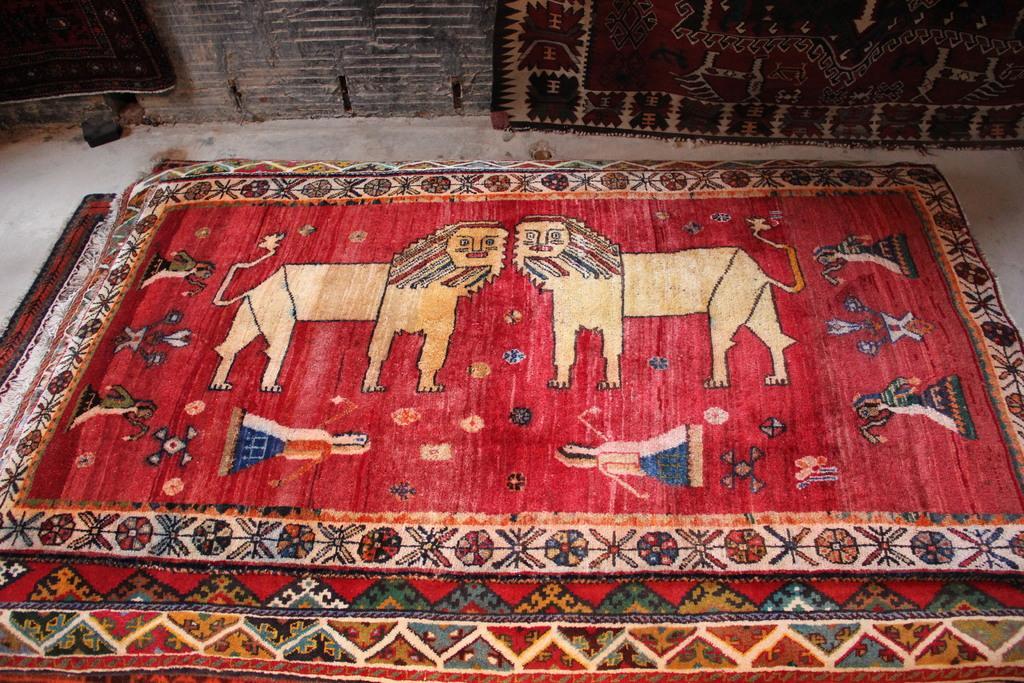In one or two sentences, can you explain what this image depicts? On the floor there are carpets. Carpets are also on the wall.  